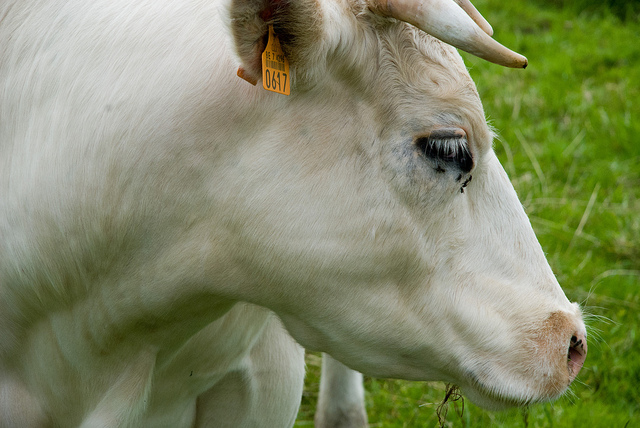Read and extract the text from this image. 0617 